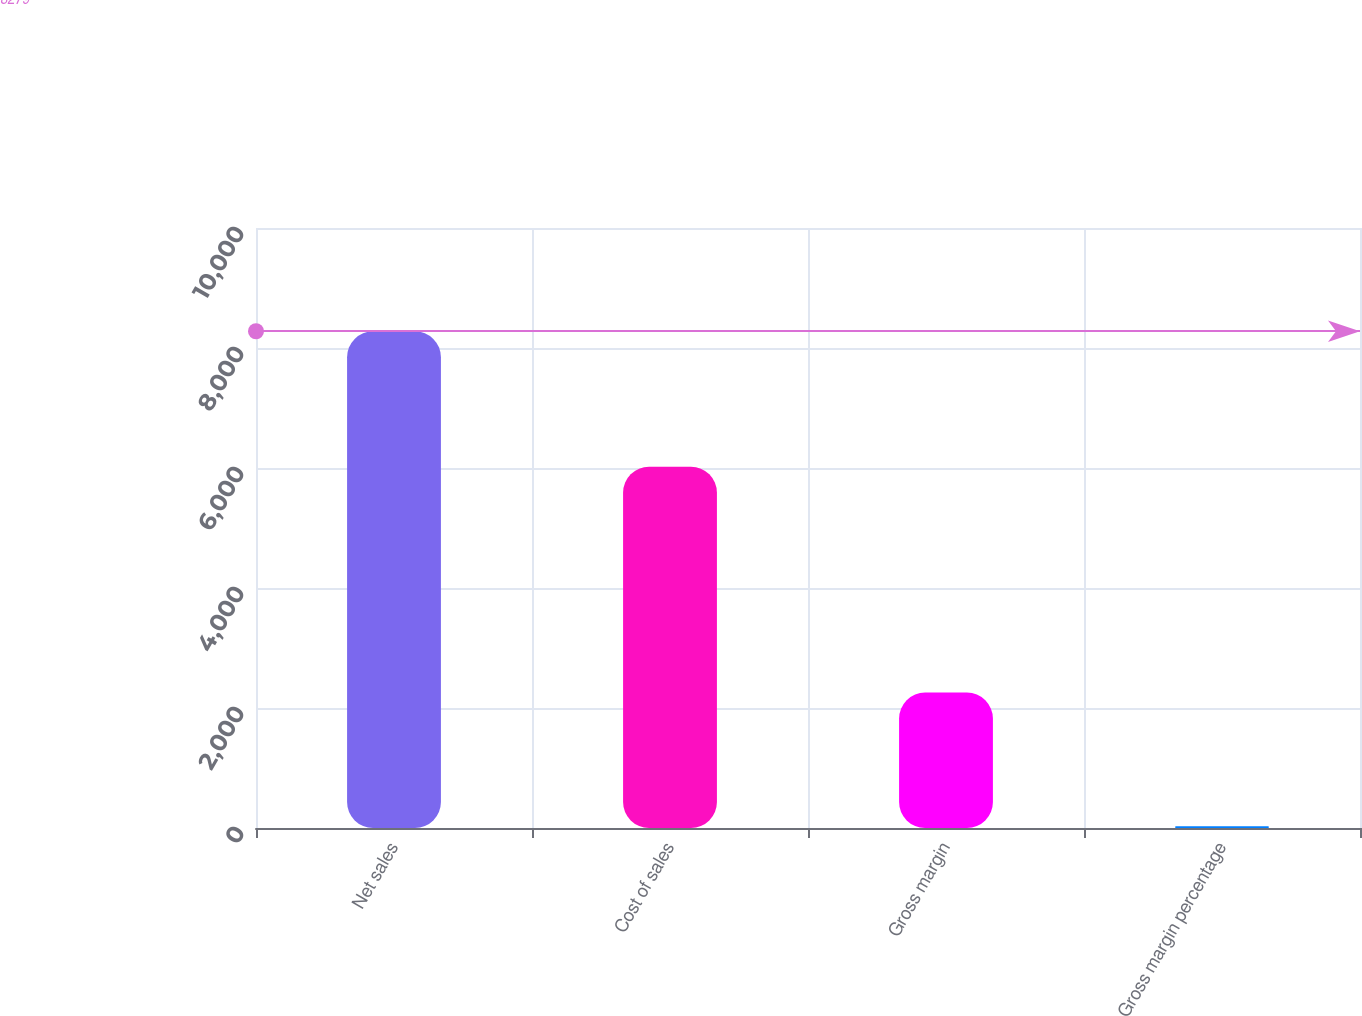<chart> <loc_0><loc_0><loc_500><loc_500><bar_chart><fcel>Net sales<fcel>Cost of sales<fcel>Gross margin<fcel>Gross margin percentage<nl><fcel>8279<fcel>6022<fcel>2257<fcel>27.3<nl></chart> 